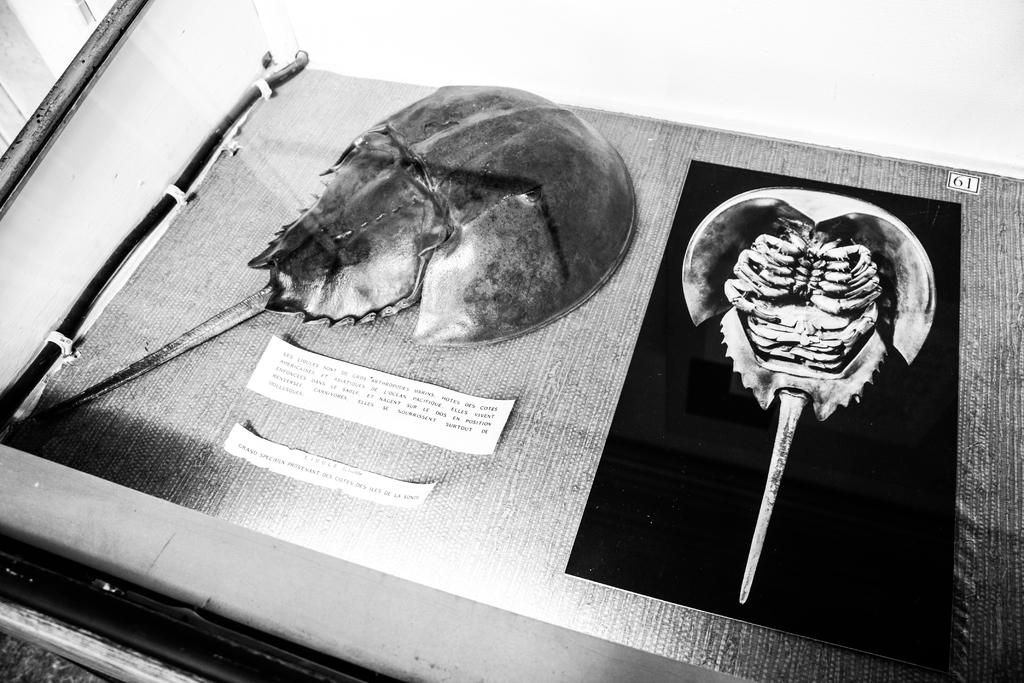What types of objects can be seen in the image? There are artifacts in the image. How can the artifacts be identified or distinguished in the image? There are labels in the image that help identify the artifacts. What type of milk is being used for the teaching activity in the image? There is no milk or teaching activity present in the image; it features artifacts with labels. How many fingers can be seen pointing at the artifacts in the image? There are no fingers visible in the image; it only shows artifacts with labels. 